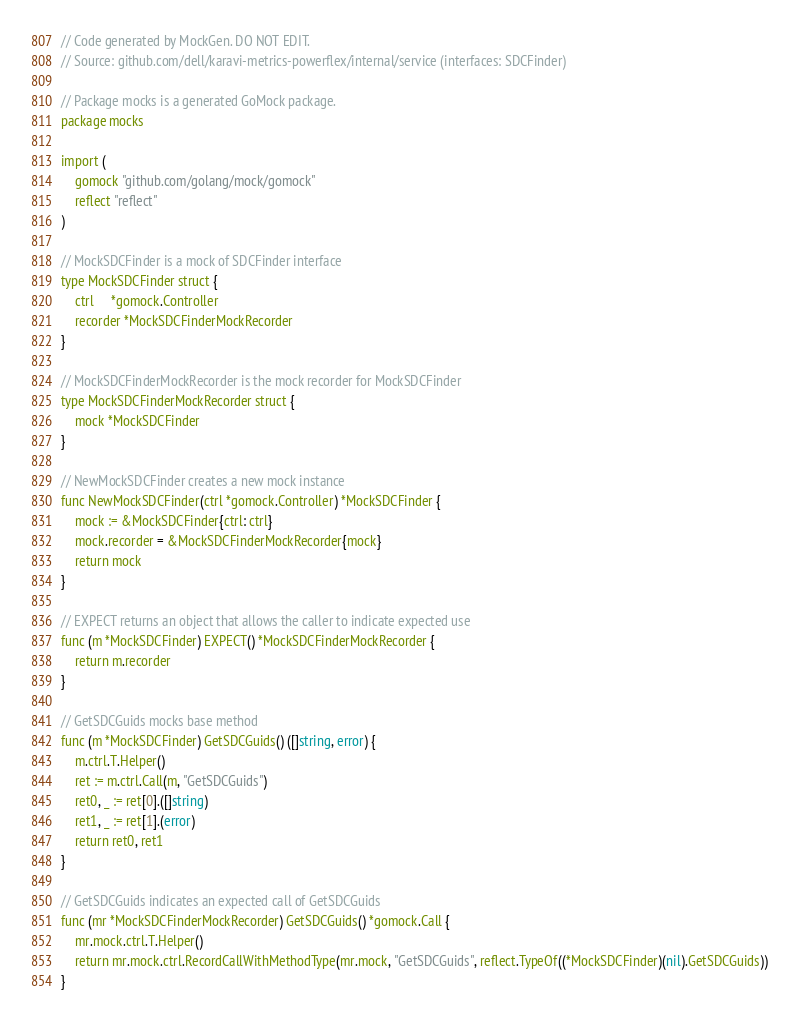Convert code to text. <code><loc_0><loc_0><loc_500><loc_500><_Go_>// Code generated by MockGen. DO NOT EDIT.
// Source: github.com/dell/karavi-metrics-powerflex/internal/service (interfaces: SDCFinder)

// Package mocks is a generated GoMock package.
package mocks

import (
	gomock "github.com/golang/mock/gomock"
	reflect "reflect"
)

// MockSDCFinder is a mock of SDCFinder interface
type MockSDCFinder struct {
	ctrl     *gomock.Controller
	recorder *MockSDCFinderMockRecorder
}

// MockSDCFinderMockRecorder is the mock recorder for MockSDCFinder
type MockSDCFinderMockRecorder struct {
	mock *MockSDCFinder
}

// NewMockSDCFinder creates a new mock instance
func NewMockSDCFinder(ctrl *gomock.Controller) *MockSDCFinder {
	mock := &MockSDCFinder{ctrl: ctrl}
	mock.recorder = &MockSDCFinderMockRecorder{mock}
	return mock
}

// EXPECT returns an object that allows the caller to indicate expected use
func (m *MockSDCFinder) EXPECT() *MockSDCFinderMockRecorder {
	return m.recorder
}

// GetSDCGuids mocks base method
func (m *MockSDCFinder) GetSDCGuids() ([]string, error) {
	m.ctrl.T.Helper()
	ret := m.ctrl.Call(m, "GetSDCGuids")
	ret0, _ := ret[0].([]string)
	ret1, _ := ret[1].(error)
	return ret0, ret1
}

// GetSDCGuids indicates an expected call of GetSDCGuids
func (mr *MockSDCFinderMockRecorder) GetSDCGuids() *gomock.Call {
	mr.mock.ctrl.T.Helper()
	return mr.mock.ctrl.RecordCallWithMethodType(mr.mock, "GetSDCGuids", reflect.TypeOf((*MockSDCFinder)(nil).GetSDCGuids))
}
</code> 